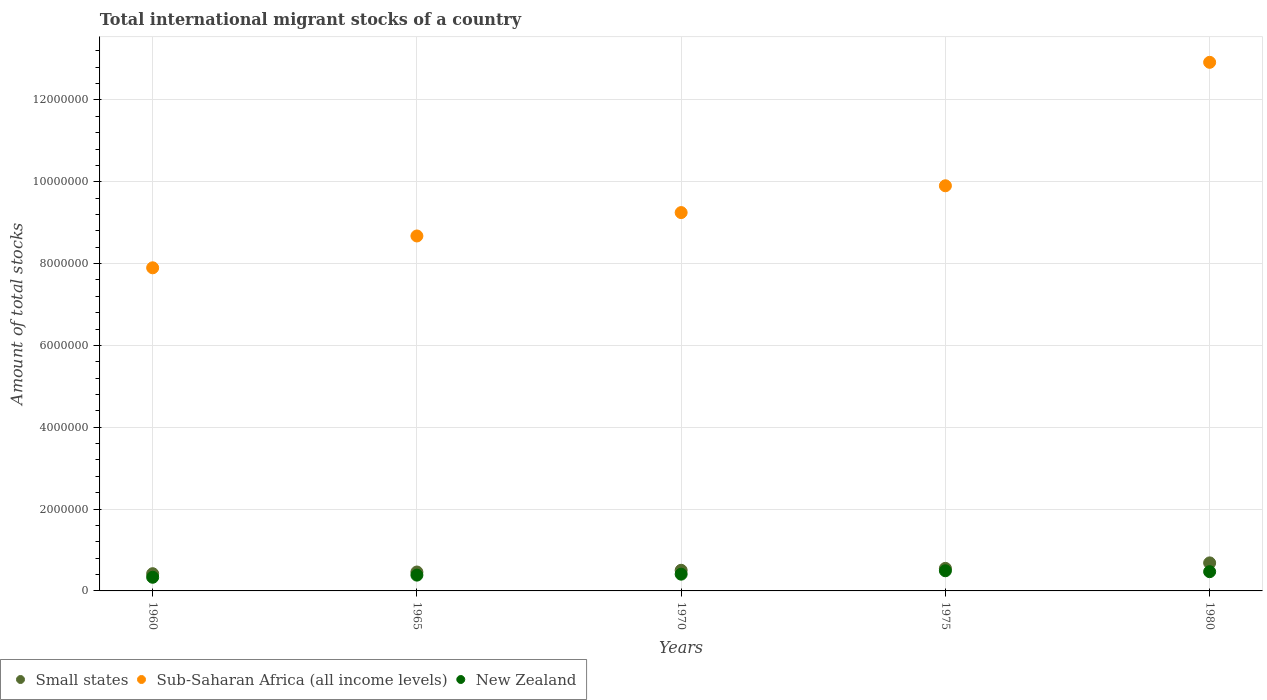Is the number of dotlines equal to the number of legend labels?
Keep it short and to the point. Yes. What is the amount of total stocks in in Small states in 1975?
Your response must be concise. 5.51e+05. Across all years, what is the maximum amount of total stocks in in Small states?
Ensure brevity in your answer.  6.85e+05. Across all years, what is the minimum amount of total stocks in in New Zealand?
Offer a very short reply. 3.34e+05. In which year was the amount of total stocks in in Sub-Saharan Africa (all income levels) maximum?
Your answer should be compact. 1980. What is the total amount of total stocks in in New Zealand in the graph?
Give a very brief answer. 2.09e+06. What is the difference between the amount of total stocks in in Sub-Saharan Africa (all income levels) in 1965 and that in 1975?
Keep it short and to the point. -1.23e+06. What is the difference between the amount of total stocks in in Small states in 1960 and the amount of total stocks in in New Zealand in 1965?
Make the answer very short. 3.48e+04. What is the average amount of total stocks in in Sub-Saharan Africa (all income levels) per year?
Your answer should be compact. 9.73e+06. In the year 1960, what is the difference between the amount of total stocks in in Sub-Saharan Africa (all income levels) and amount of total stocks in in New Zealand?
Provide a short and direct response. 7.56e+06. What is the ratio of the amount of total stocks in in New Zealand in 1960 to that in 1965?
Keep it short and to the point. 0.86. Is the difference between the amount of total stocks in in Sub-Saharan Africa (all income levels) in 1965 and 1980 greater than the difference between the amount of total stocks in in New Zealand in 1965 and 1980?
Provide a short and direct response. No. What is the difference between the highest and the second highest amount of total stocks in in Sub-Saharan Africa (all income levels)?
Offer a terse response. 3.02e+06. What is the difference between the highest and the lowest amount of total stocks in in Small states?
Your answer should be very brief. 2.64e+05. In how many years, is the amount of total stocks in in Sub-Saharan Africa (all income levels) greater than the average amount of total stocks in in Sub-Saharan Africa (all income levels) taken over all years?
Give a very brief answer. 2. Is it the case that in every year, the sum of the amount of total stocks in in Sub-Saharan Africa (all income levels) and amount of total stocks in in Small states  is greater than the amount of total stocks in in New Zealand?
Make the answer very short. Yes. Does the amount of total stocks in in Sub-Saharan Africa (all income levels) monotonically increase over the years?
Give a very brief answer. Yes. Is the amount of total stocks in in New Zealand strictly less than the amount of total stocks in in Small states over the years?
Provide a succinct answer. Yes. How many dotlines are there?
Provide a short and direct response. 3. Are the values on the major ticks of Y-axis written in scientific E-notation?
Ensure brevity in your answer.  No. Does the graph contain grids?
Keep it short and to the point. Yes. What is the title of the graph?
Provide a succinct answer. Total international migrant stocks of a country. What is the label or title of the Y-axis?
Your answer should be compact. Amount of total stocks. What is the Amount of total stocks of Small states in 1960?
Offer a terse response. 4.21e+05. What is the Amount of total stocks in Sub-Saharan Africa (all income levels) in 1960?
Offer a very short reply. 7.90e+06. What is the Amount of total stocks of New Zealand in 1960?
Ensure brevity in your answer.  3.34e+05. What is the Amount of total stocks in Small states in 1965?
Your response must be concise. 4.62e+05. What is the Amount of total stocks of Sub-Saharan Africa (all income levels) in 1965?
Offer a terse response. 8.68e+06. What is the Amount of total stocks of New Zealand in 1965?
Offer a terse response. 3.86e+05. What is the Amount of total stocks of Small states in 1970?
Ensure brevity in your answer.  5.04e+05. What is the Amount of total stocks in Sub-Saharan Africa (all income levels) in 1970?
Keep it short and to the point. 9.25e+06. What is the Amount of total stocks in New Zealand in 1970?
Give a very brief answer. 4.09e+05. What is the Amount of total stocks in Small states in 1975?
Give a very brief answer. 5.51e+05. What is the Amount of total stocks of Sub-Saharan Africa (all income levels) in 1975?
Your response must be concise. 9.90e+06. What is the Amount of total stocks of New Zealand in 1975?
Provide a short and direct response. 4.93e+05. What is the Amount of total stocks of Small states in 1980?
Your answer should be compact. 6.85e+05. What is the Amount of total stocks in Sub-Saharan Africa (all income levels) in 1980?
Give a very brief answer. 1.29e+07. What is the Amount of total stocks of New Zealand in 1980?
Offer a very short reply. 4.70e+05. Across all years, what is the maximum Amount of total stocks of Small states?
Provide a succinct answer. 6.85e+05. Across all years, what is the maximum Amount of total stocks of Sub-Saharan Africa (all income levels)?
Give a very brief answer. 1.29e+07. Across all years, what is the maximum Amount of total stocks of New Zealand?
Make the answer very short. 4.93e+05. Across all years, what is the minimum Amount of total stocks in Small states?
Your answer should be compact. 4.21e+05. Across all years, what is the minimum Amount of total stocks of Sub-Saharan Africa (all income levels)?
Offer a very short reply. 7.90e+06. Across all years, what is the minimum Amount of total stocks of New Zealand?
Offer a very short reply. 3.34e+05. What is the total Amount of total stocks in Small states in the graph?
Your answer should be compact. 2.62e+06. What is the total Amount of total stocks of Sub-Saharan Africa (all income levels) in the graph?
Your answer should be compact. 4.86e+07. What is the total Amount of total stocks in New Zealand in the graph?
Make the answer very short. 2.09e+06. What is the difference between the Amount of total stocks in Small states in 1960 and that in 1965?
Ensure brevity in your answer.  -4.14e+04. What is the difference between the Amount of total stocks in Sub-Saharan Africa (all income levels) in 1960 and that in 1965?
Keep it short and to the point. -7.78e+05. What is the difference between the Amount of total stocks of New Zealand in 1960 and that in 1965?
Offer a very short reply. -5.23e+04. What is the difference between the Amount of total stocks of Small states in 1960 and that in 1970?
Ensure brevity in your answer.  -8.35e+04. What is the difference between the Amount of total stocks of Sub-Saharan Africa (all income levels) in 1960 and that in 1970?
Make the answer very short. -1.35e+06. What is the difference between the Amount of total stocks in New Zealand in 1960 and that in 1970?
Ensure brevity in your answer.  -7.56e+04. What is the difference between the Amount of total stocks of Small states in 1960 and that in 1975?
Make the answer very short. -1.30e+05. What is the difference between the Amount of total stocks in Sub-Saharan Africa (all income levels) in 1960 and that in 1975?
Your response must be concise. -2.00e+06. What is the difference between the Amount of total stocks of New Zealand in 1960 and that in 1975?
Provide a short and direct response. -1.59e+05. What is the difference between the Amount of total stocks of Small states in 1960 and that in 1980?
Provide a succinct answer. -2.64e+05. What is the difference between the Amount of total stocks in Sub-Saharan Africa (all income levels) in 1960 and that in 1980?
Give a very brief answer. -5.02e+06. What is the difference between the Amount of total stocks of New Zealand in 1960 and that in 1980?
Provide a short and direct response. -1.37e+05. What is the difference between the Amount of total stocks of Small states in 1965 and that in 1970?
Offer a terse response. -4.21e+04. What is the difference between the Amount of total stocks in Sub-Saharan Africa (all income levels) in 1965 and that in 1970?
Provide a succinct answer. -5.72e+05. What is the difference between the Amount of total stocks of New Zealand in 1965 and that in 1970?
Keep it short and to the point. -2.33e+04. What is the difference between the Amount of total stocks of Small states in 1965 and that in 1975?
Offer a very short reply. -8.87e+04. What is the difference between the Amount of total stocks in Sub-Saharan Africa (all income levels) in 1965 and that in 1975?
Provide a short and direct response. -1.23e+06. What is the difference between the Amount of total stocks in New Zealand in 1965 and that in 1975?
Your answer should be compact. -1.07e+05. What is the difference between the Amount of total stocks in Small states in 1965 and that in 1980?
Your response must be concise. -2.23e+05. What is the difference between the Amount of total stocks in Sub-Saharan Africa (all income levels) in 1965 and that in 1980?
Offer a very short reply. -4.24e+06. What is the difference between the Amount of total stocks in New Zealand in 1965 and that in 1980?
Make the answer very short. -8.42e+04. What is the difference between the Amount of total stocks in Small states in 1970 and that in 1975?
Offer a very short reply. -4.66e+04. What is the difference between the Amount of total stocks in Sub-Saharan Africa (all income levels) in 1970 and that in 1975?
Offer a very short reply. -6.55e+05. What is the difference between the Amount of total stocks in New Zealand in 1970 and that in 1975?
Offer a terse response. -8.34e+04. What is the difference between the Amount of total stocks of Small states in 1970 and that in 1980?
Ensure brevity in your answer.  -1.81e+05. What is the difference between the Amount of total stocks in Sub-Saharan Africa (all income levels) in 1970 and that in 1980?
Keep it short and to the point. -3.67e+06. What is the difference between the Amount of total stocks of New Zealand in 1970 and that in 1980?
Your response must be concise. -6.09e+04. What is the difference between the Amount of total stocks in Small states in 1975 and that in 1980?
Keep it short and to the point. -1.34e+05. What is the difference between the Amount of total stocks in Sub-Saharan Africa (all income levels) in 1975 and that in 1980?
Keep it short and to the point. -3.02e+06. What is the difference between the Amount of total stocks in New Zealand in 1975 and that in 1980?
Provide a succinct answer. 2.25e+04. What is the difference between the Amount of total stocks in Small states in 1960 and the Amount of total stocks in Sub-Saharan Africa (all income levels) in 1965?
Offer a very short reply. -8.25e+06. What is the difference between the Amount of total stocks in Small states in 1960 and the Amount of total stocks in New Zealand in 1965?
Provide a short and direct response. 3.48e+04. What is the difference between the Amount of total stocks of Sub-Saharan Africa (all income levels) in 1960 and the Amount of total stocks of New Zealand in 1965?
Offer a terse response. 7.51e+06. What is the difference between the Amount of total stocks in Small states in 1960 and the Amount of total stocks in Sub-Saharan Africa (all income levels) in 1970?
Your answer should be very brief. -8.83e+06. What is the difference between the Amount of total stocks of Small states in 1960 and the Amount of total stocks of New Zealand in 1970?
Your response must be concise. 1.15e+04. What is the difference between the Amount of total stocks in Sub-Saharan Africa (all income levels) in 1960 and the Amount of total stocks in New Zealand in 1970?
Give a very brief answer. 7.49e+06. What is the difference between the Amount of total stocks of Small states in 1960 and the Amount of total stocks of Sub-Saharan Africa (all income levels) in 1975?
Offer a very short reply. -9.48e+06. What is the difference between the Amount of total stocks of Small states in 1960 and the Amount of total stocks of New Zealand in 1975?
Ensure brevity in your answer.  -7.19e+04. What is the difference between the Amount of total stocks in Sub-Saharan Africa (all income levels) in 1960 and the Amount of total stocks in New Zealand in 1975?
Keep it short and to the point. 7.40e+06. What is the difference between the Amount of total stocks of Small states in 1960 and the Amount of total stocks of Sub-Saharan Africa (all income levels) in 1980?
Keep it short and to the point. -1.25e+07. What is the difference between the Amount of total stocks of Small states in 1960 and the Amount of total stocks of New Zealand in 1980?
Give a very brief answer. -4.95e+04. What is the difference between the Amount of total stocks in Sub-Saharan Africa (all income levels) in 1960 and the Amount of total stocks in New Zealand in 1980?
Provide a short and direct response. 7.43e+06. What is the difference between the Amount of total stocks of Small states in 1965 and the Amount of total stocks of Sub-Saharan Africa (all income levels) in 1970?
Keep it short and to the point. -8.78e+06. What is the difference between the Amount of total stocks of Small states in 1965 and the Amount of total stocks of New Zealand in 1970?
Give a very brief answer. 5.28e+04. What is the difference between the Amount of total stocks in Sub-Saharan Africa (all income levels) in 1965 and the Amount of total stocks in New Zealand in 1970?
Ensure brevity in your answer.  8.27e+06. What is the difference between the Amount of total stocks in Small states in 1965 and the Amount of total stocks in Sub-Saharan Africa (all income levels) in 1975?
Provide a succinct answer. -9.44e+06. What is the difference between the Amount of total stocks of Small states in 1965 and the Amount of total stocks of New Zealand in 1975?
Ensure brevity in your answer.  -3.06e+04. What is the difference between the Amount of total stocks of Sub-Saharan Africa (all income levels) in 1965 and the Amount of total stocks of New Zealand in 1975?
Provide a succinct answer. 8.18e+06. What is the difference between the Amount of total stocks of Small states in 1965 and the Amount of total stocks of Sub-Saharan Africa (all income levels) in 1980?
Your response must be concise. -1.25e+07. What is the difference between the Amount of total stocks in Small states in 1965 and the Amount of total stocks in New Zealand in 1980?
Offer a terse response. -8102. What is the difference between the Amount of total stocks in Sub-Saharan Africa (all income levels) in 1965 and the Amount of total stocks in New Zealand in 1980?
Your answer should be very brief. 8.20e+06. What is the difference between the Amount of total stocks of Small states in 1970 and the Amount of total stocks of Sub-Saharan Africa (all income levels) in 1975?
Keep it short and to the point. -9.40e+06. What is the difference between the Amount of total stocks in Small states in 1970 and the Amount of total stocks in New Zealand in 1975?
Your answer should be very brief. 1.15e+04. What is the difference between the Amount of total stocks of Sub-Saharan Africa (all income levels) in 1970 and the Amount of total stocks of New Zealand in 1975?
Offer a terse response. 8.75e+06. What is the difference between the Amount of total stocks in Small states in 1970 and the Amount of total stocks in Sub-Saharan Africa (all income levels) in 1980?
Keep it short and to the point. -1.24e+07. What is the difference between the Amount of total stocks of Small states in 1970 and the Amount of total stocks of New Zealand in 1980?
Offer a very short reply. 3.40e+04. What is the difference between the Amount of total stocks of Sub-Saharan Africa (all income levels) in 1970 and the Amount of total stocks of New Zealand in 1980?
Offer a terse response. 8.78e+06. What is the difference between the Amount of total stocks in Small states in 1975 and the Amount of total stocks in Sub-Saharan Africa (all income levels) in 1980?
Give a very brief answer. -1.24e+07. What is the difference between the Amount of total stocks in Small states in 1975 and the Amount of total stocks in New Zealand in 1980?
Provide a short and direct response. 8.06e+04. What is the difference between the Amount of total stocks in Sub-Saharan Africa (all income levels) in 1975 and the Amount of total stocks in New Zealand in 1980?
Your answer should be very brief. 9.43e+06. What is the average Amount of total stocks in Small states per year?
Offer a terse response. 5.25e+05. What is the average Amount of total stocks of Sub-Saharan Africa (all income levels) per year?
Keep it short and to the point. 9.73e+06. What is the average Amount of total stocks in New Zealand per year?
Offer a terse response. 4.19e+05. In the year 1960, what is the difference between the Amount of total stocks in Small states and Amount of total stocks in Sub-Saharan Africa (all income levels)?
Make the answer very short. -7.48e+06. In the year 1960, what is the difference between the Amount of total stocks in Small states and Amount of total stocks in New Zealand?
Provide a succinct answer. 8.71e+04. In the year 1960, what is the difference between the Amount of total stocks of Sub-Saharan Africa (all income levels) and Amount of total stocks of New Zealand?
Your answer should be very brief. 7.56e+06. In the year 1965, what is the difference between the Amount of total stocks of Small states and Amount of total stocks of Sub-Saharan Africa (all income levels)?
Offer a terse response. -8.21e+06. In the year 1965, what is the difference between the Amount of total stocks in Small states and Amount of total stocks in New Zealand?
Give a very brief answer. 7.61e+04. In the year 1965, what is the difference between the Amount of total stocks of Sub-Saharan Africa (all income levels) and Amount of total stocks of New Zealand?
Your answer should be compact. 8.29e+06. In the year 1970, what is the difference between the Amount of total stocks of Small states and Amount of total stocks of Sub-Saharan Africa (all income levels)?
Your answer should be compact. -8.74e+06. In the year 1970, what is the difference between the Amount of total stocks of Small states and Amount of total stocks of New Zealand?
Offer a terse response. 9.49e+04. In the year 1970, what is the difference between the Amount of total stocks of Sub-Saharan Africa (all income levels) and Amount of total stocks of New Zealand?
Ensure brevity in your answer.  8.84e+06. In the year 1975, what is the difference between the Amount of total stocks of Small states and Amount of total stocks of Sub-Saharan Africa (all income levels)?
Provide a short and direct response. -9.35e+06. In the year 1975, what is the difference between the Amount of total stocks in Small states and Amount of total stocks in New Zealand?
Offer a terse response. 5.81e+04. In the year 1975, what is the difference between the Amount of total stocks of Sub-Saharan Africa (all income levels) and Amount of total stocks of New Zealand?
Ensure brevity in your answer.  9.41e+06. In the year 1980, what is the difference between the Amount of total stocks of Small states and Amount of total stocks of Sub-Saharan Africa (all income levels)?
Offer a terse response. -1.22e+07. In the year 1980, what is the difference between the Amount of total stocks of Small states and Amount of total stocks of New Zealand?
Your answer should be very brief. 2.15e+05. In the year 1980, what is the difference between the Amount of total stocks of Sub-Saharan Africa (all income levels) and Amount of total stocks of New Zealand?
Your answer should be very brief. 1.24e+07. What is the ratio of the Amount of total stocks in Small states in 1960 to that in 1965?
Provide a succinct answer. 0.91. What is the ratio of the Amount of total stocks in Sub-Saharan Africa (all income levels) in 1960 to that in 1965?
Provide a short and direct response. 0.91. What is the ratio of the Amount of total stocks of New Zealand in 1960 to that in 1965?
Give a very brief answer. 0.86. What is the ratio of the Amount of total stocks in Small states in 1960 to that in 1970?
Your answer should be compact. 0.83. What is the ratio of the Amount of total stocks of Sub-Saharan Africa (all income levels) in 1960 to that in 1970?
Your answer should be compact. 0.85. What is the ratio of the Amount of total stocks of New Zealand in 1960 to that in 1970?
Make the answer very short. 0.82. What is the ratio of the Amount of total stocks in Small states in 1960 to that in 1975?
Offer a terse response. 0.76. What is the ratio of the Amount of total stocks of Sub-Saharan Africa (all income levels) in 1960 to that in 1975?
Provide a succinct answer. 0.8. What is the ratio of the Amount of total stocks in New Zealand in 1960 to that in 1975?
Keep it short and to the point. 0.68. What is the ratio of the Amount of total stocks in Small states in 1960 to that in 1980?
Make the answer very short. 0.61. What is the ratio of the Amount of total stocks in Sub-Saharan Africa (all income levels) in 1960 to that in 1980?
Your response must be concise. 0.61. What is the ratio of the Amount of total stocks of New Zealand in 1960 to that in 1980?
Give a very brief answer. 0.71. What is the ratio of the Amount of total stocks of Small states in 1965 to that in 1970?
Offer a terse response. 0.92. What is the ratio of the Amount of total stocks of Sub-Saharan Africa (all income levels) in 1965 to that in 1970?
Give a very brief answer. 0.94. What is the ratio of the Amount of total stocks of New Zealand in 1965 to that in 1970?
Ensure brevity in your answer.  0.94. What is the ratio of the Amount of total stocks of Small states in 1965 to that in 1975?
Offer a terse response. 0.84. What is the ratio of the Amount of total stocks of Sub-Saharan Africa (all income levels) in 1965 to that in 1975?
Your response must be concise. 0.88. What is the ratio of the Amount of total stocks in New Zealand in 1965 to that in 1975?
Offer a terse response. 0.78. What is the ratio of the Amount of total stocks of Small states in 1965 to that in 1980?
Ensure brevity in your answer.  0.67. What is the ratio of the Amount of total stocks of Sub-Saharan Africa (all income levels) in 1965 to that in 1980?
Your response must be concise. 0.67. What is the ratio of the Amount of total stocks of New Zealand in 1965 to that in 1980?
Give a very brief answer. 0.82. What is the ratio of the Amount of total stocks in Small states in 1970 to that in 1975?
Keep it short and to the point. 0.92. What is the ratio of the Amount of total stocks of Sub-Saharan Africa (all income levels) in 1970 to that in 1975?
Your answer should be very brief. 0.93. What is the ratio of the Amount of total stocks in New Zealand in 1970 to that in 1975?
Provide a succinct answer. 0.83. What is the ratio of the Amount of total stocks of Small states in 1970 to that in 1980?
Give a very brief answer. 0.74. What is the ratio of the Amount of total stocks of Sub-Saharan Africa (all income levels) in 1970 to that in 1980?
Your answer should be compact. 0.72. What is the ratio of the Amount of total stocks in New Zealand in 1970 to that in 1980?
Offer a terse response. 0.87. What is the ratio of the Amount of total stocks of Small states in 1975 to that in 1980?
Offer a terse response. 0.8. What is the ratio of the Amount of total stocks in Sub-Saharan Africa (all income levels) in 1975 to that in 1980?
Ensure brevity in your answer.  0.77. What is the ratio of the Amount of total stocks in New Zealand in 1975 to that in 1980?
Your response must be concise. 1.05. What is the difference between the highest and the second highest Amount of total stocks of Small states?
Give a very brief answer. 1.34e+05. What is the difference between the highest and the second highest Amount of total stocks of Sub-Saharan Africa (all income levels)?
Give a very brief answer. 3.02e+06. What is the difference between the highest and the second highest Amount of total stocks in New Zealand?
Make the answer very short. 2.25e+04. What is the difference between the highest and the lowest Amount of total stocks in Small states?
Provide a short and direct response. 2.64e+05. What is the difference between the highest and the lowest Amount of total stocks of Sub-Saharan Africa (all income levels)?
Provide a short and direct response. 5.02e+06. What is the difference between the highest and the lowest Amount of total stocks of New Zealand?
Offer a very short reply. 1.59e+05. 